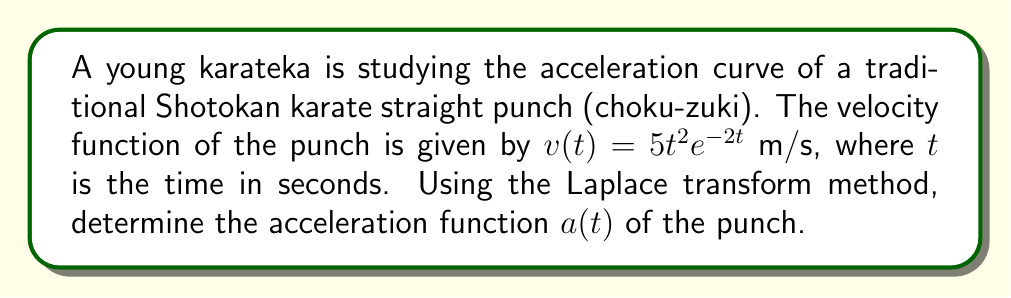What is the answer to this math problem? To solve this problem, we'll follow these steps:

1) First, we need to find the Laplace transform of the velocity function.
2) Then, we'll use the property of Laplace transforms that states: if $F(s)$ is the Laplace transform of $f(t)$, then $sF(s) - f(0)$ is the Laplace transform of $f'(t)$.
3) Finally, we'll find the inverse Laplace transform to get the acceleration function.

Step 1: Find the Laplace transform of $v(t) = 5t^2e^{-2t}$

Let $V(s)$ be the Laplace transform of $v(t)$. We know that the Laplace transform of $t^ne^{at}$ is $\frac{n!}{(s-a)^{n+1}}$.

Therefore, $V(s) = 5 \cdot \frac{2!}{(s+2)^3} = \frac{10}{(s+2)^3}$

Step 2: Use the Laplace transform property for derivatives

The Laplace transform of acceleration $a(t)$ is:

$A(s) = sV(s) - v(0)$

We know $v(0) = 0$, so:

$A(s) = sV(s) = s \cdot \frac{10}{(s+2)^3} = \frac{10s}{(s+2)^3}$

Step 3: Find the inverse Laplace transform

To find the inverse Laplace transform, we can use partial fraction decomposition:

$\frac{10s}{(s+2)^3} = \frac{10}{(s+2)^2} - \frac{20}{(s+2)^3}$

Now, we can use the inverse Laplace transform formulas:

$\mathcal{L}^{-1}\{\frac{1}{(s+a)^2}\} = te^{-at}$
$\mathcal{L}^{-1}\{\frac{1}{(s+a)^3}\} = \frac{1}{2}t^2e^{-at}$

Therefore, the acceleration function is:

$a(t) = 10te^{-2t} - 10t^2e^{-2t} = 10e^{-2t}(t - t^2)$
Answer: $a(t) = 10e^{-2t}(t - t^2)$ m/s² 